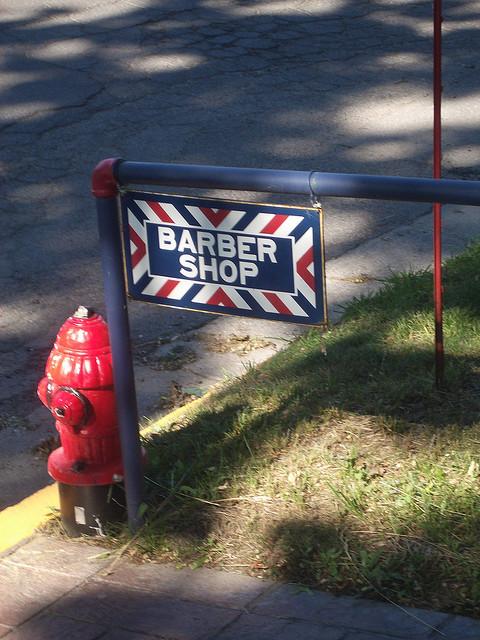Is the grass healthy or dying in the photograph?
Quick response, please. Healthy. Where is the brick sidewalk?
Quick response, please. By grass. What does the sign say?
Answer briefly. Barber shop. 